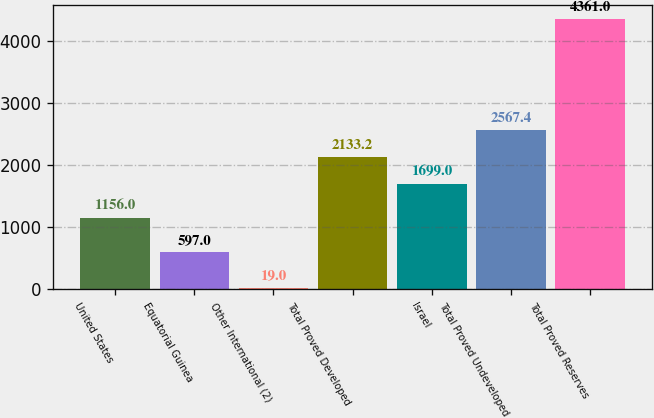Convert chart to OTSL. <chart><loc_0><loc_0><loc_500><loc_500><bar_chart><fcel>United States<fcel>Equatorial Guinea<fcel>Other International (2)<fcel>Total Proved Developed<fcel>Israel<fcel>Total Proved Undeveloped<fcel>Total Proved Reserves<nl><fcel>1156<fcel>597<fcel>19<fcel>2133.2<fcel>1699<fcel>2567.4<fcel>4361<nl></chart> 